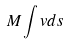Convert formula to latex. <formula><loc_0><loc_0><loc_500><loc_500>M \int v d s</formula> 